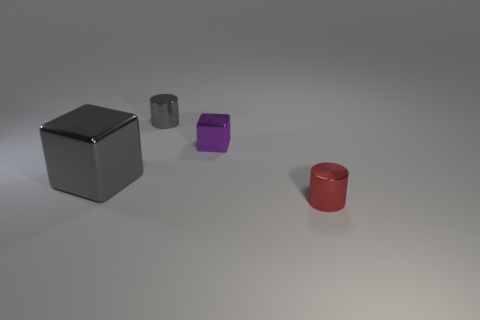Is the number of small metallic things to the left of the big gray metal object the same as the number of big gray metal cubes? No, it isn't. There are two small metallic objects to the left of the big gray cube, but there is only one big gray cube in the image. 